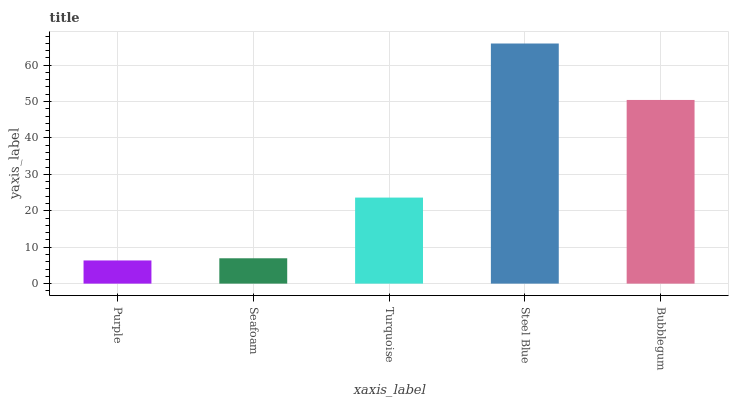Is Purple the minimum?
Answer yes or no. Yes. Is Steel Blue the maximum?
Answer yes or no. Yes. Is Seafoam the minimum?
Answer yes or no. No. Is Seafoam the maximum?
Answer yes or no. No. Is Seafoam greater than Purple?
Answer yes or no. Yes. Is Purple less than Seafoam?
Answer yes or no. Yes. Is Purple greater than Seafoam?
Answer yes or no. No. Is Seafoam less than Purple?
Answer yes or no. No. Is Turquoise the high median?
Answer yes or no. Yes. Is Turquoise the low median?
Answer yes or no. Yes. Is Seafoam the high median?
Answer yes or no. No. Is Purple the low median?
Answer yes or no. No. 